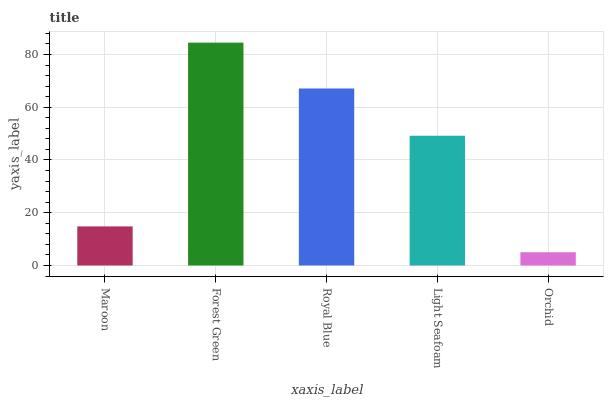Is Orchid the minimum?
Answer yes or no. Yes. Is Forest Green the maximum?
Answer yes or no. Yes. Is Royal Blue the minimum?
Answer yes or no. No. Is Royal Blue the maximum?
Answer yes or no. No. Is Forest Green greater than Royal Blue?
Answer yes or no. Yes. Is Royal Blue less than Forest Green?
Answer yes or no. Yes. Is Royal Blue greater than Forest Green?
Answer yes or no. No. Is Forest Green less than Royal Blue?
Answer yes or no. No. Is Light Seafoam the high median?
Answer yes or no. Yes. Is Light Seafoam the low median?
Answer yes or no. Yes. Is Forest Green the high median?
Answer yes or no. No. Is Forest Green the low median?
Answer yes or no. No. 